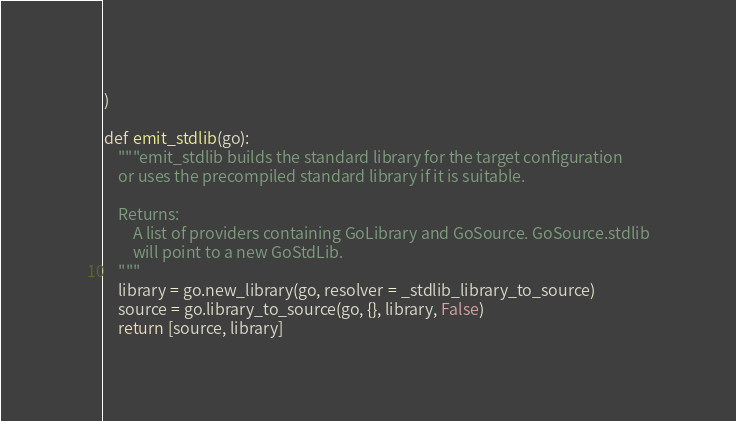Convert code to text. <code><loc_0><loc_0><loc_500><loc_500><_Python_>)

def emit_stdlib(go):
    """emit_stdlib builds the standard library for the target configuration
    or uses the precompiled standard library if it is suitable.

    Returns:
        A list of providers containing GoLibrary and GoSource. GoSource.stdlib
        will point to a new GoStdLib.
    """
    library = go.new_library(go, resolver = _stdlib_library_to_source)
    source = go.library_to_source(go, {}, library, False)
    return [source, library]
</code> 